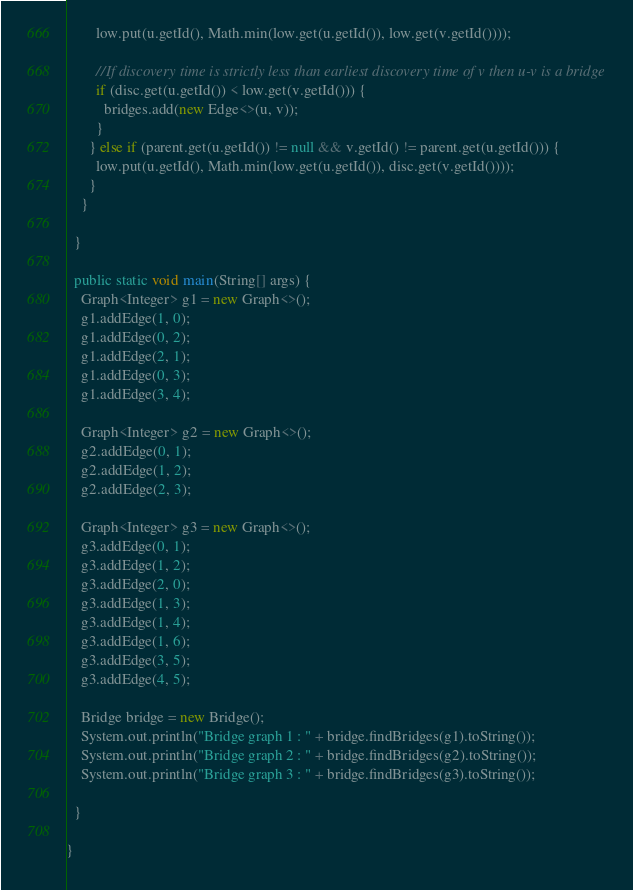Convert code to text. <code><loc_0><loc_0><loc_500><loc_500><_Java_>        low.put(u.getId(), Math.min(low.get(u.getId()), low.get(v.getId())));

        //If discovery time is strictly less than earliest discovery time of v then u-v is a bridge
        if (disc.get(u.getId()) < low.get(v.getId())) {
          bridges.add(new Edge<>(u, v));
        }
      } else if (parent.get(u.getId()) != null && v.getId() != parent.get(u.getId())) {
        low.put(u.getId(), Math.min(low.get(u.getId()), disc.get(v.getId())));
      }
    }

  }

  public static void main(String[] args) {
    Graph<Integer> g1 = new Graph<>();
    g1.addEdge(1, 0);
    g1.addEdge(0, 2);
    g1.addEdge(2, 1);
    g1.addEdge(0, 3);
    g1.addEdge(3, 4);

    Graph<Integer> g2 = new Graph<>();
    g2.addEdge(0, 1);
    g2.addEdge(1, 2);
    g2.addEdge(2, 3);

    Graph<Integer> g3 = new Graph<>();
    g3.addEdge(0, 1);
    g3.addEdge(1, 2);
    g3.addEdge(2, 0);
    g3.addEdge(1, 3);
    g3.addEdge(1, 4);
    g3.addEdge(1, 6);
    g3.addEdge(3, 5);
    g3.addEdge(4, 5);

    Bridge bridge = new Bridge();
    System.out.println("Bridge graph 1 : " + bridge.findBridges(g1).toString());
    System.out.println("Bridge graph 2 : " + bridge.findBridges(g2).toString());
    System.out.println("Bridge graph 3 : " + bridge.findBridges(g3).toString());

  }

}
</code> 